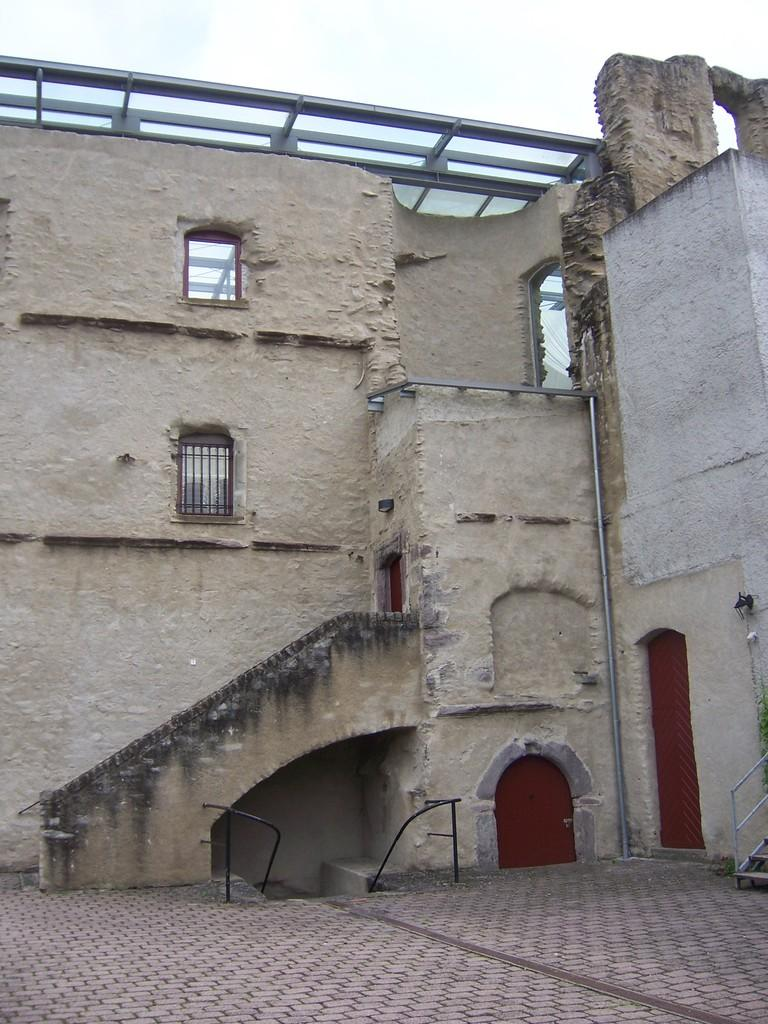What is the main surface visible in the image? There is a ground in the image. What structure is located on the ground? There is a building on the ground. What features does the building have? The building has doors and a rooftop. How can one access the building? There are stairs in the image that can be used to access the building. What is visible above the building? The sky is visible in the image. Can you see a basin filled with water on the rooftop of the building in the image? There is no basin filled with water visible on the rooftop of the building in the image. Is there a wren perched on the door of the building in the image? There is no wren present in the image. 